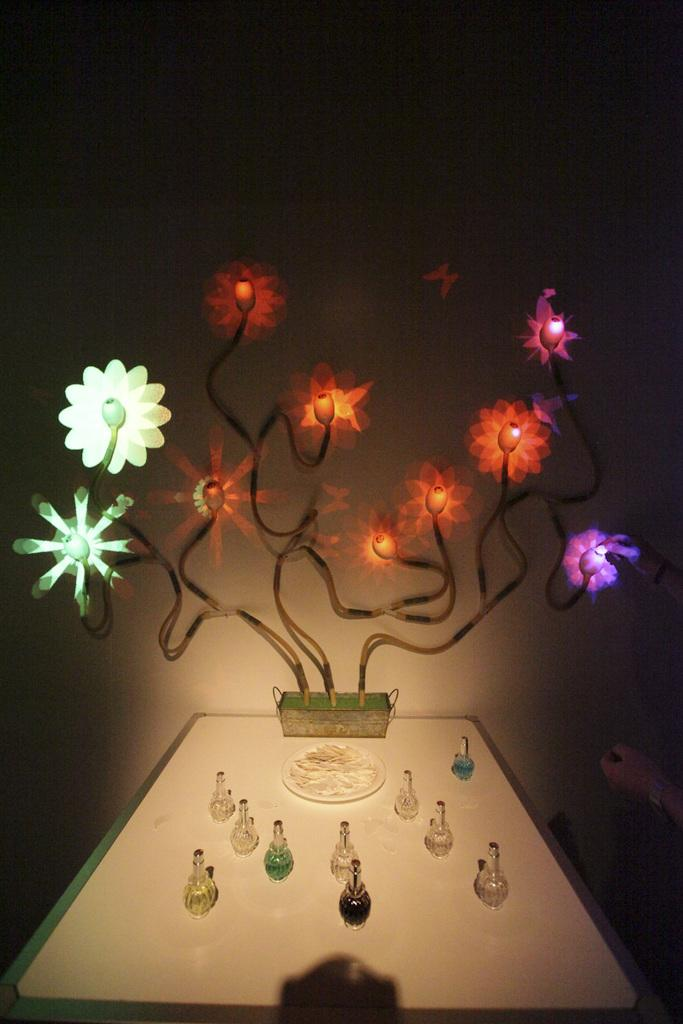What objects are placed on the table at the bottom of the image? There are bottles placed on a table at the bottom of the image. What can be seen in the center of the image? There are decorations visible in the center of the image. What is the background of the image? There is a wall present in the image. How many kittens are sitting on the wall in the image? There are no kittens present in the image; only bottles, decorations, and a wall can be seen. 